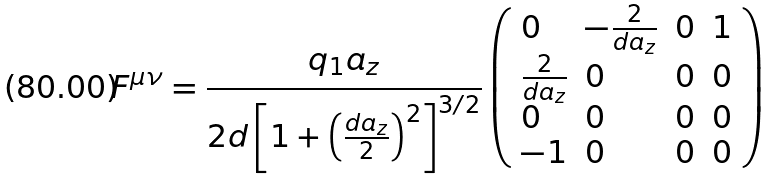Convert formula to latex. <formula><loc_0><loc_0><loc_500><loc_500>F ^ { \mu \nu } = \frac { q _ { 1 } a _ { z } } { 2 d \left [ 1 + \left ( \frac { d a _ { z } } { 2 } \right ) ^ { 2 } \right ] ^ { 3 / 2 } } \left ( \begin{array} { l l l l } 0 & - \frac { 2 } { d a _ { z } } & 0 & 1 \\ \frac { 2 } { d a _ { z } } & 0 & 0 & 0 \\ 0 & 0 & 0 & 0 \\ - 1 & 0 & 0 & 0 \\ \end{array} \right )</formula> 